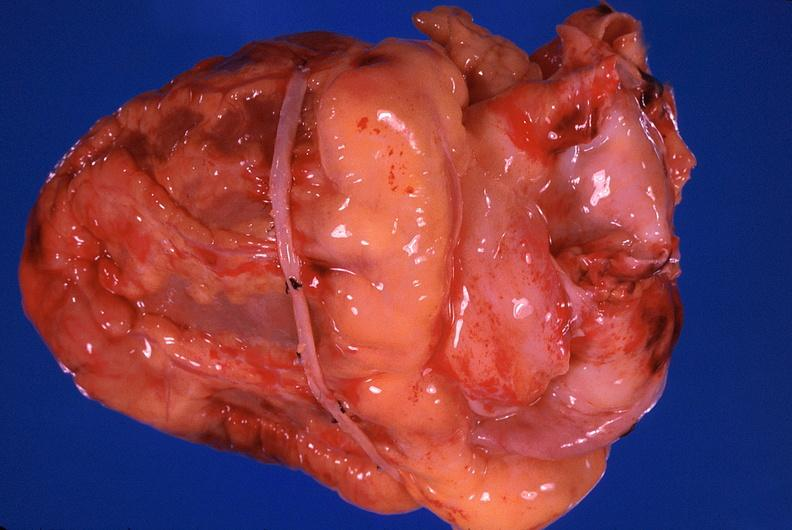where is this?
Answer the question using a single word or phrase. Heart 